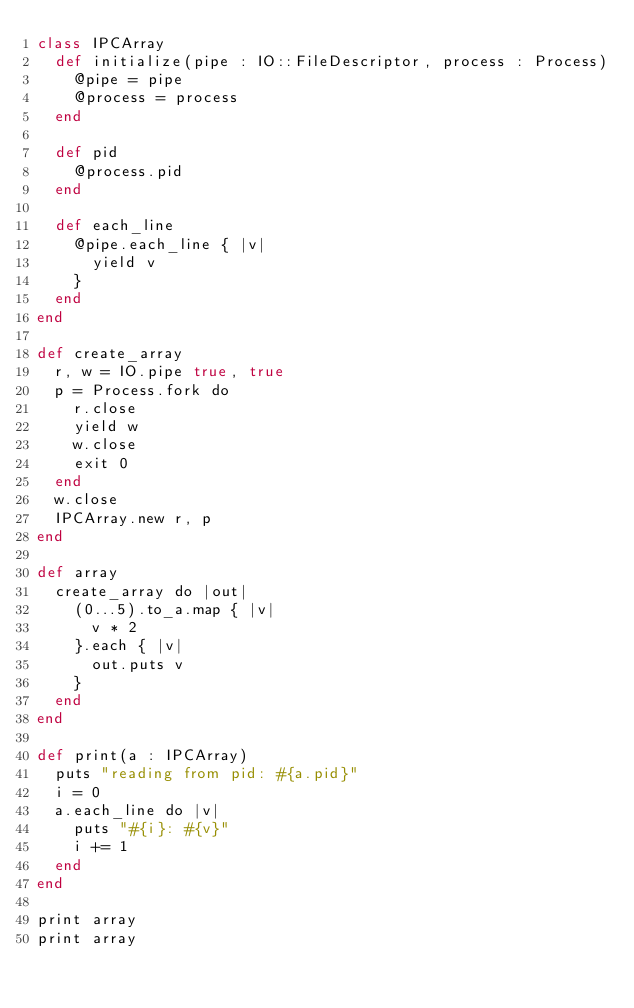Convert code to text. <code><loc_0><loc_0><loc_500><loc_500><_Crystal_>class IPCArray
	def initialize(pipe : IO::FileDescriptor, process : Process)
		@pipe = pipe
		@process = process
	end

	def pid
		@process.pid
	end

	def each_line
		@pipe.each_line { |v|
			yield v
		}
	end
end

def create_array
	r, w = IO.pipe true, true
	p = Process.fork do
		r.close
		yield w
		w.close
		exit 0
	end
	w.close
	IPCArray.new r, p
end

def array
	create_array do |out|
		(0...5).to_a.map { |v|
			v * 2
		}.each { |v|
			out.puts v
		}
	end
end

def print(a : IPCArray)
	puts "reading from pid: #{a.pid}"
	i = 0
	a.each_line do |v|
		puts "#{i}: #{v}"
		i += 1
	end
end

print array
print array</code> 